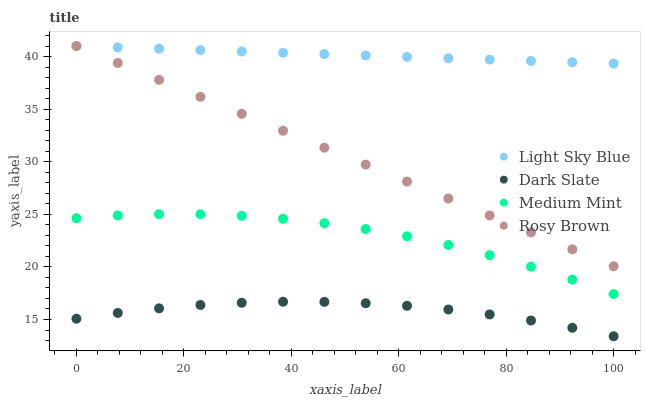Does Dark Slate have the minimum area under the curve?
Answer yes or no. Yes. Does Light Sky Blue have the maximum area under the curve?
Answer yes or no. Yes. Does Rosy Brown have the minimum area under the curve?
Answer yes or no. No. Does Rosy Brown have the maximum area under the curve?
Answer yes or no. No. Is Rosy Brown the smoothest?
Answer yes or no. Yes. Is Medium Mint the roughest?
Answer yes or no. Yes. Is Dark Slate the smoothest?
Answer yes or no. No. Is Dark Slate the roughest?
Answer yes or no. No. Does Dark Slate have the lowest value?
Answer yes or no. Yes. Does Rosy Brown have the lowest value?
Answer yes or no. No. Does Light Sky Blue have the highest value?
Answer yes or no. Yes. Does Dark Slate have the highest value?
Answer yes or no. No. Is Medium Mint less than Rosy Brown?
Answer yes or no. Yes. Is Light Sky Blue greater than Medium Mint?
Answer yes or no. Yes. Does Rosy Brown intersect Light Sky Blue?
Answer yes or no. Yes. Is Rosy Brown less than Light Sky Blue?
Answer yes or no. No. Is Rosy Brown greater than Light Sky Blue?
Answer yes or no. No. Does Medium Mint intersect Rosy Brown?
Answer yes or no. No. 